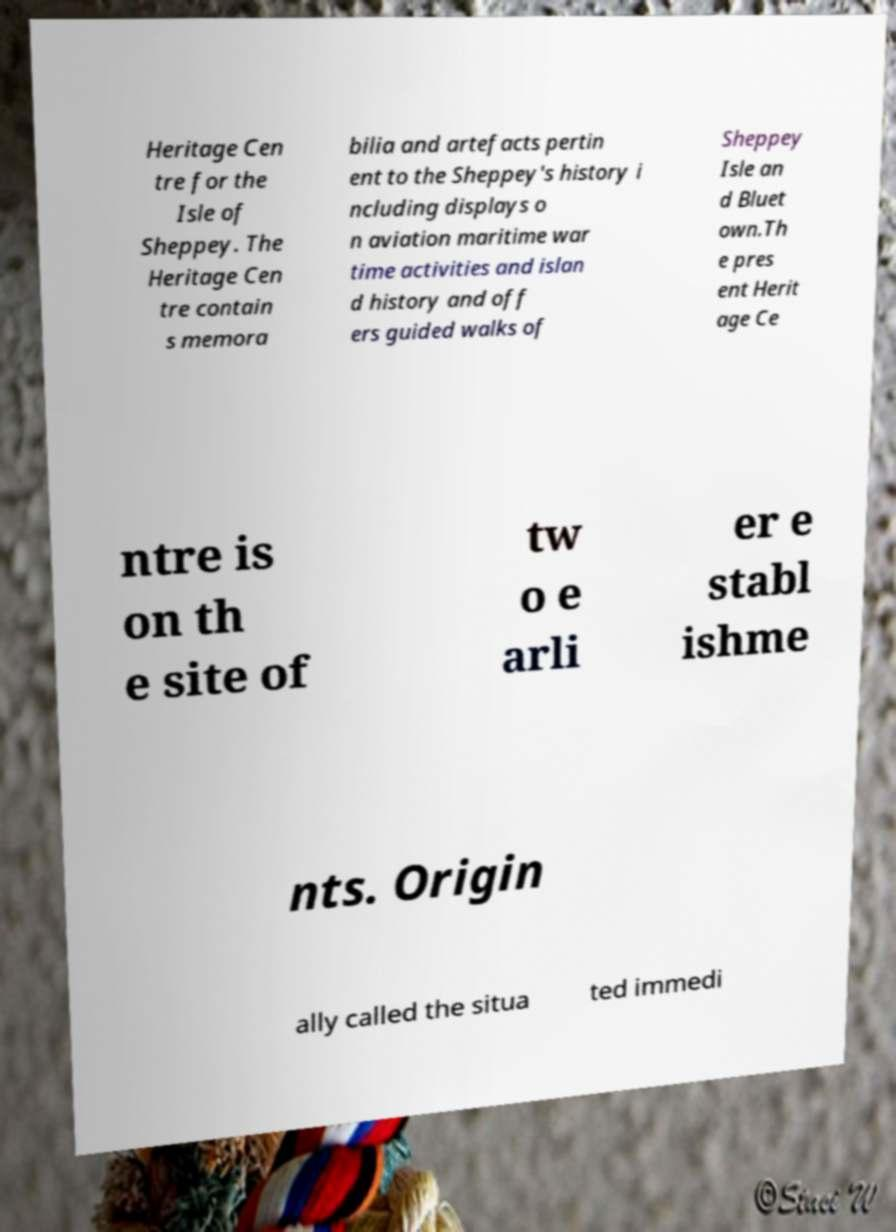There's text embedded in this image that I need extracted. Can you transcribe it verbatim? Heritage Cen tre for the Isle of Sheppey. The Heritage Cen tre contain s memora bilia and artefacts pertin ent to the Sheppey's history i ncluding displays o n aviation maritime war time activities and islan d history and off ers guided walks of Sheppey Isle an d Bluet own.Th e pres ent Herit age Ce ntre is on th e site of tw o e arli er e stabl ishme nts. Origin ally called the situa ted immedi 